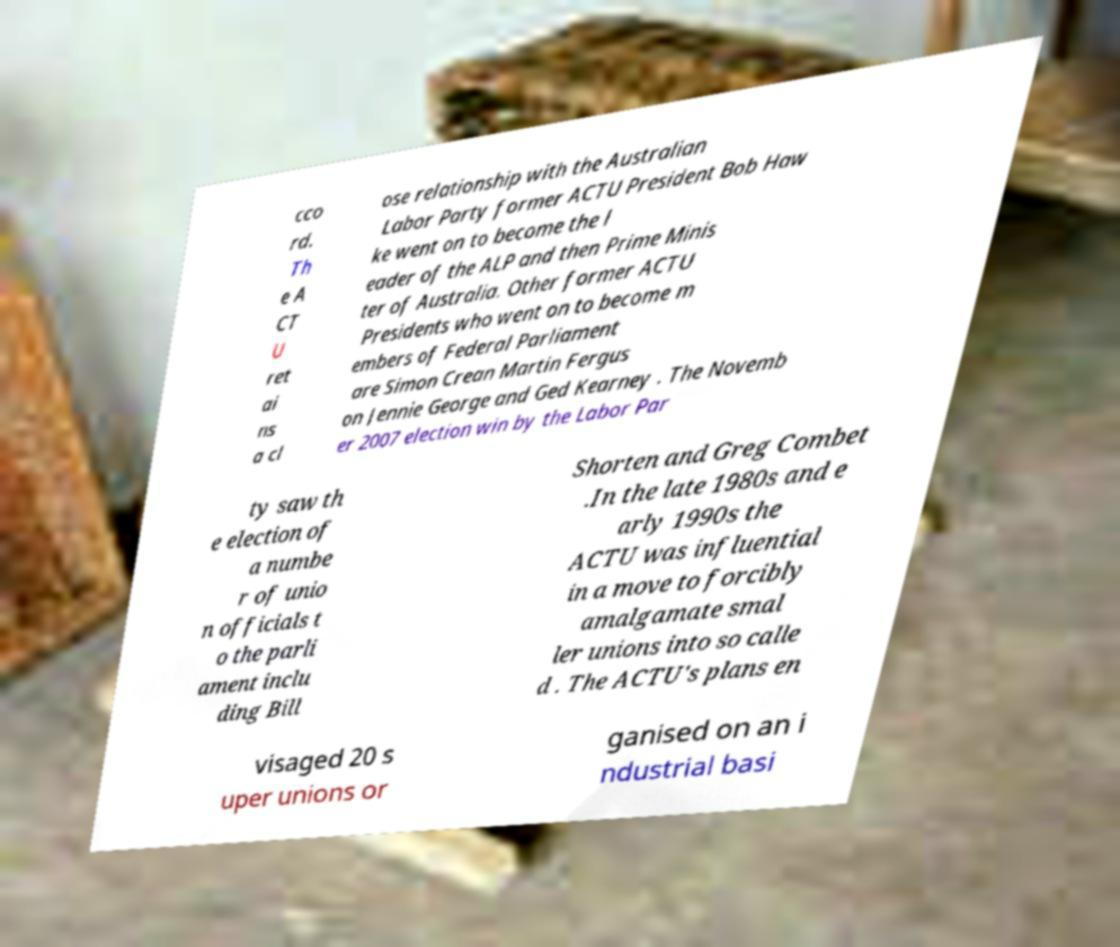Can you accurately transcribe the text from the provided image for me? cco rd. Th e A CT U ret ai ns a cl ose relationship with the Australian Labor Party former ACTU President Bob Haw ke went on to become the l eader of the ALP and then Prime Minis ter of Australia. Other former ACTU Presidents who went on to become m embers of Federal Parliament are Simon Crean Martin Fergus on Jennie George and Ged Kearney . The Novemb er 2007 election win by the Labor Par ty saw th e election of a numbe r of unio n officials t o the parli ament inclu ding Bill Shorten and Greg Combet .In the late 1980s and e arly 1990s the ACTU was influential in a move to forcibly amalgamate smal ler unions into so calle d . The ACTU's plans en visaged 20 s uper unions or ganised on an i ndustrial basi 